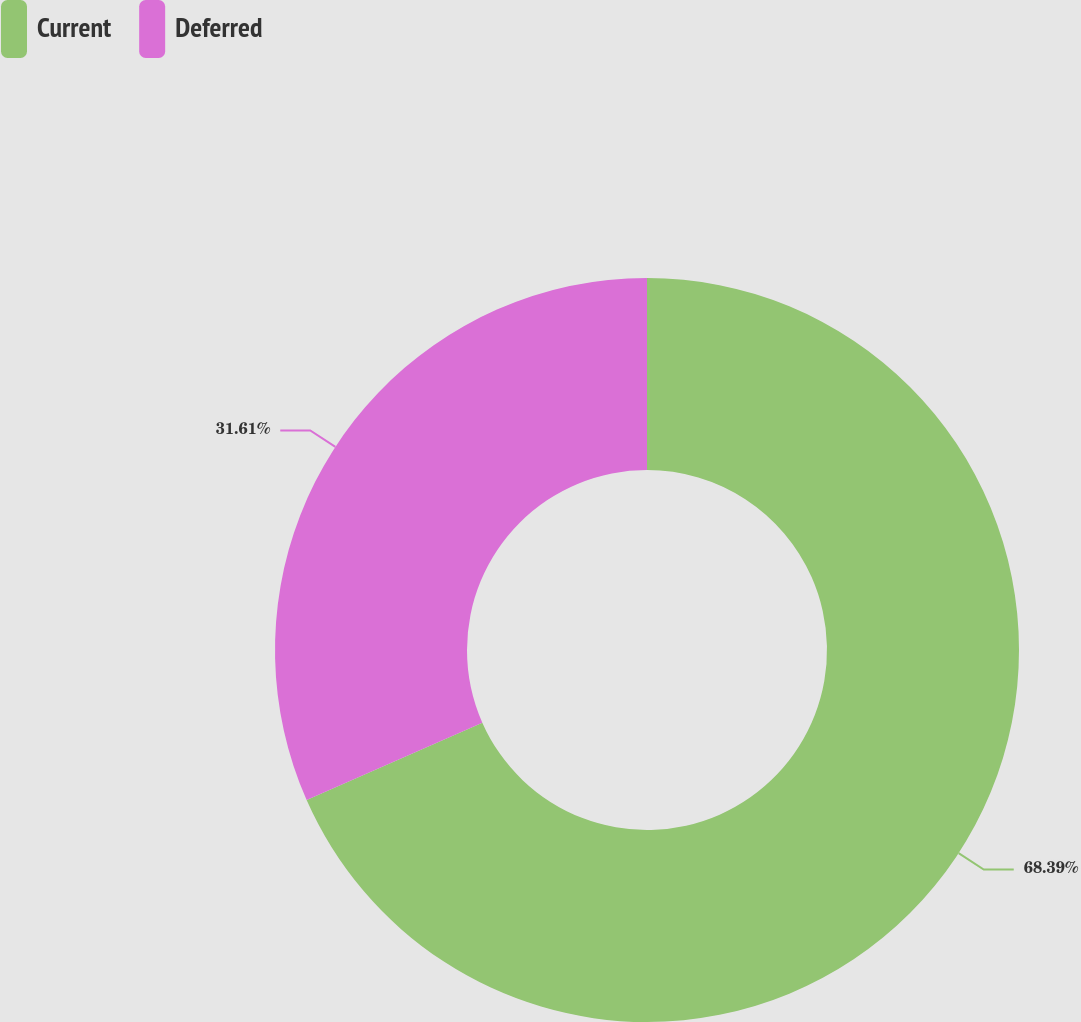Convert chart to OTSL. <chart><loc_0><loc_0><loc_500><loc_500><pie_chart><fcel>Current<fcel>Deferred<nl><fcel>68.39%<fcel>31.61%<nl></chart> 